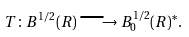Convert formula to latex. <formula><loc_0><loc_0><loc_500><loc_500>T \colon B ^ { 1 / 2 } ( { R } ) \longrightarrow B ^ { 1 / 2 } _ { 0 } ( { R } ) ^ { * } .</formula> 